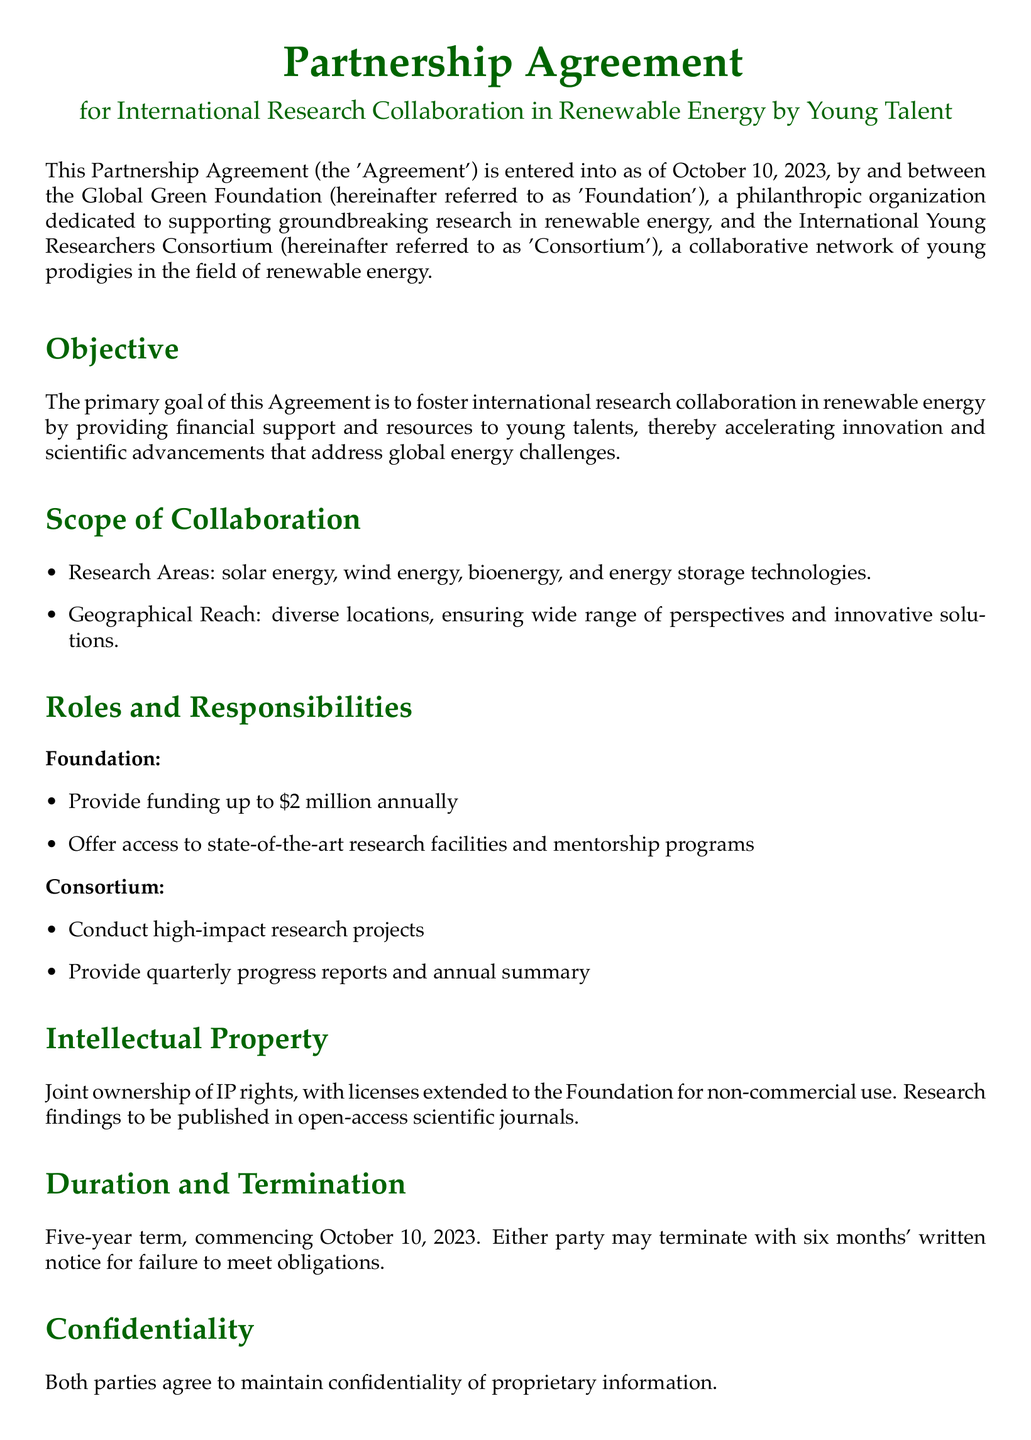What is the date of the agreement? The agreement date is specified in the introduction of the document.
Answer: October 10, 2023 Who is the CEO of the Global Green Foundation? The signature section lists the name of the CEO.
Answer: Jane Doe What is the maximum funding amount per year? The roles and responsibilities section outlines the funding limit provided by the Foundation.
Answer: $2 million What is the duration of the partnership? The duration is mentioned in the section discussing the term and termination of the agreement.
Answer: Five years Which research areas are included in the collaboration? The scope of collaboration section lists the research areas.
Answer: solar energy, wind energy, bioenergy, and energy storage technologies What is required for termination of the agreement? The termination section specifies the notice period needed for termination.
Answer: Six months' written notice What type of ownership is established for intellectual property? The intellectual property section describes the ownership rights involved.
Answer: Joint ownership What mechanism is used for dispute resolution? The dispute resolution section mentions how disputes will be settled.
Answer: Binding arbitration 